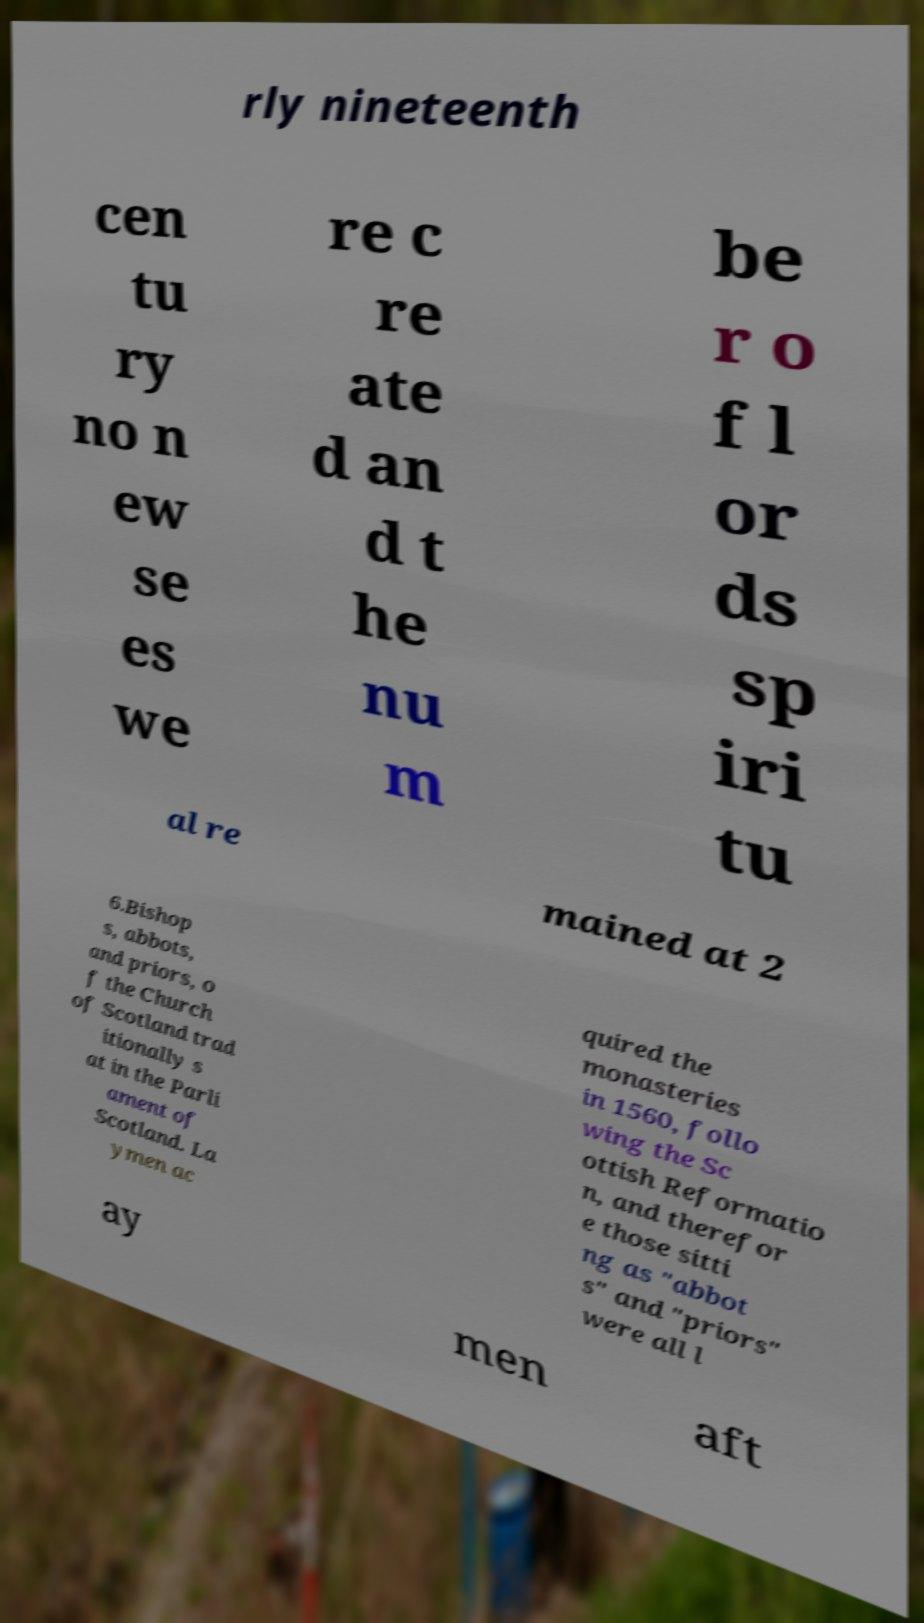Can you accurately transcribe the text from the provided image for me? rly nineteenth cen tu ry no n ew se es we re c re ate d an d t he nu m be r o f l or ds sp iri tu al re mained at 2 6.Bishop s, abbots, and priors, o f the Church of Scotland trad itionally s at in the Parli ament of Scotland. La ymen ac quired the monasteries in 1560, follo wing the Sc ottish Reformatio n, and therefor e those sitti ng as "abbot s" and "priors" were all l ay men aft 